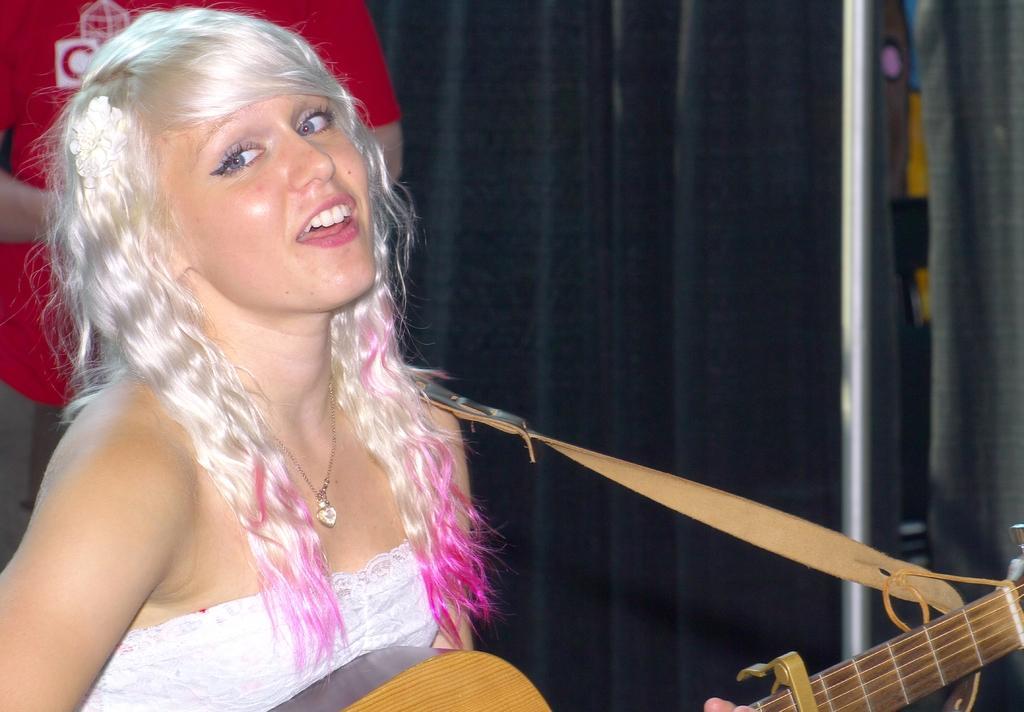In one or two sentences, can you explain what this image depicts? In this image I can see a girl and she is holding a guitar. I can also see she is wearing a necklace and white dress. In the background I can see one more person. 